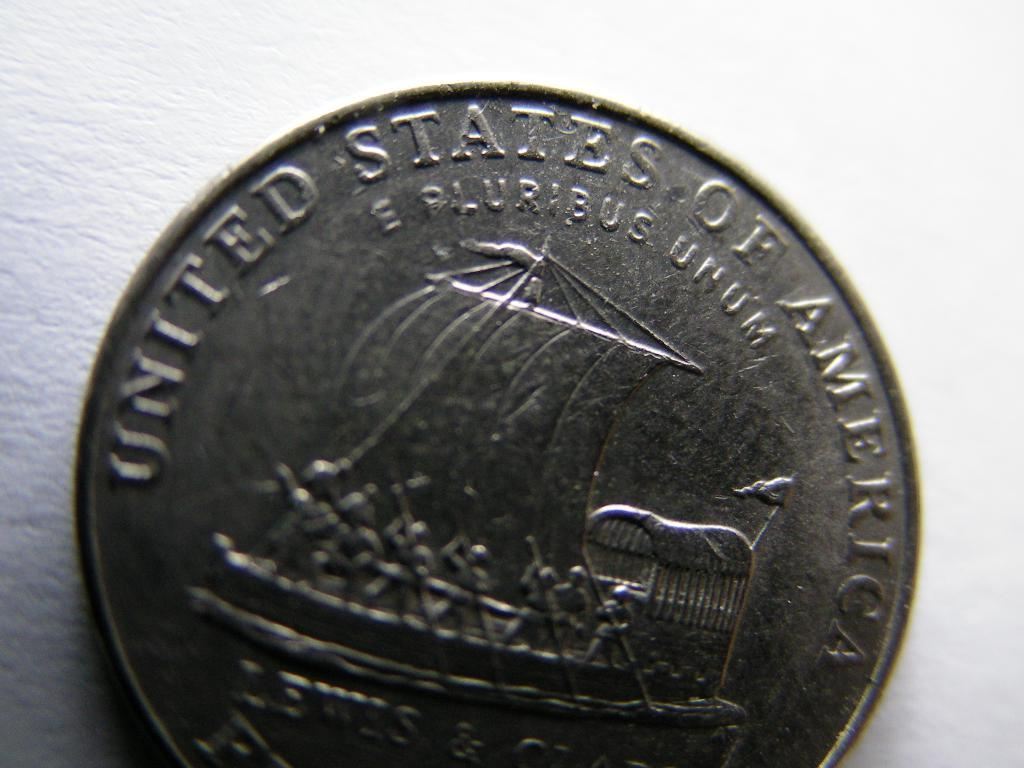<image>
Share a concise interpretation of the image provided. a quarter from the united states of america 